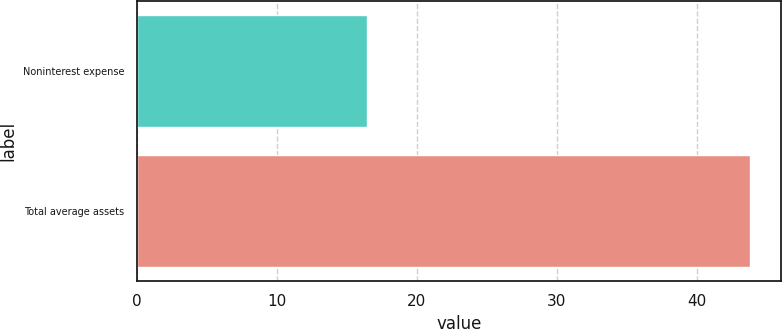Convert chart. <chart><loc_0><loc_0><loc_500><loc_500><bar_chart><fcel>Noninterest expense<fcel>Total average assets<nl><fcel>16.4<fcel>43.8<nl></chart> 